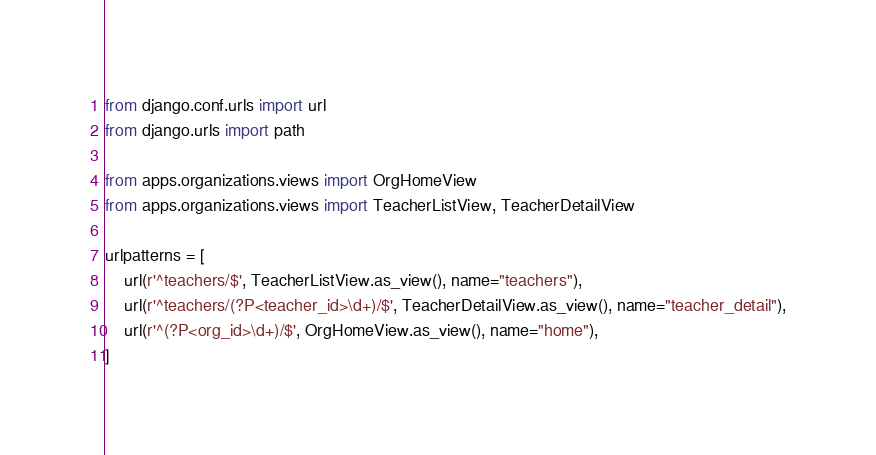Convert code to text. <code><loc_0><loc_0><loc_500><loc_500><_Python_>from django.conf.urls import url
from django.urls import path

from apps.organizations.views import OrgHomeView
from apps.organizations.views import TeacherListView, TeacherDetailView

urlpatterns = [
    url(r'^teachers/$', TeacherListView.as_view(), name="teachers"),
    url(r'^teachers/(?P<teacher_id>\d+)/$', TeacherDetailView.as_view(), name="teacher_detail"),
    url(r'^(?P<org_id>\d+)/$', OrgHomeView.as_view(), name="home"),
]
</code> 